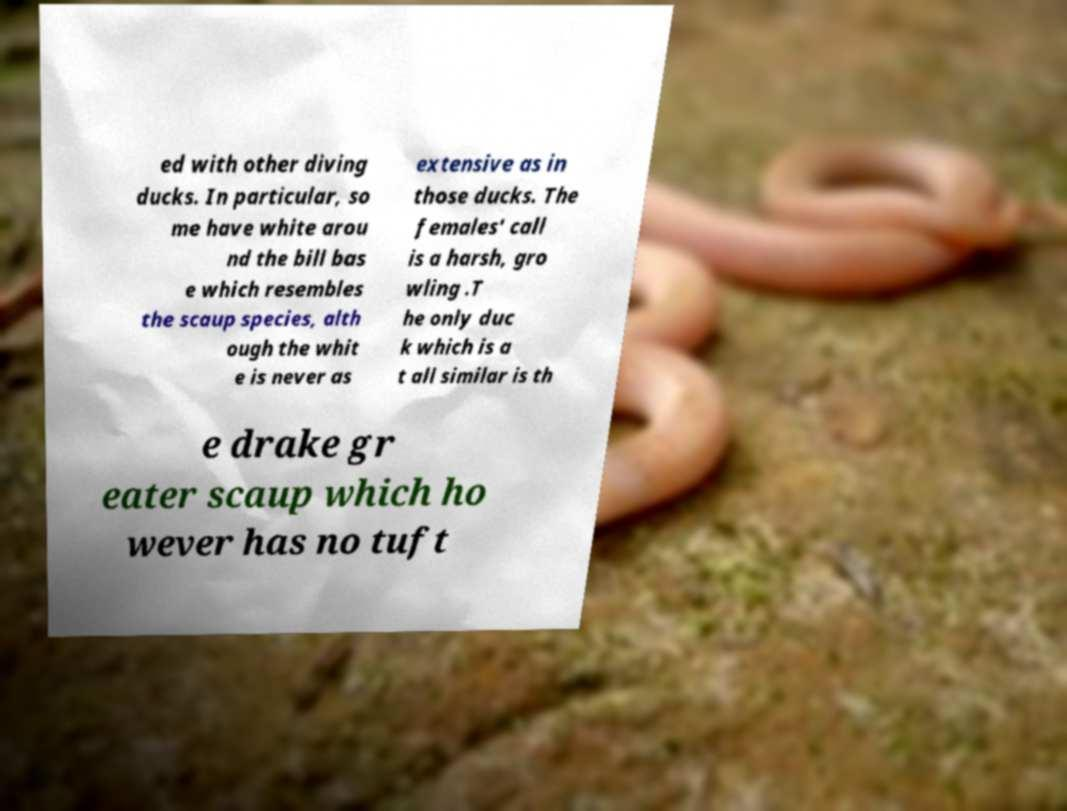For documentation purposes, I need the text within this image transcribed. Could you provide that? ed with other diving ducks. In particular, so me have white arou nd the bill bas e which resembles the scaup species, alth ough the whit e is never as extensive as in those ducks. The females' call is a harsh, gro wling .T he only duc k which is a t all similar is th e drake gr eater scaup which ho wever has no tuft 